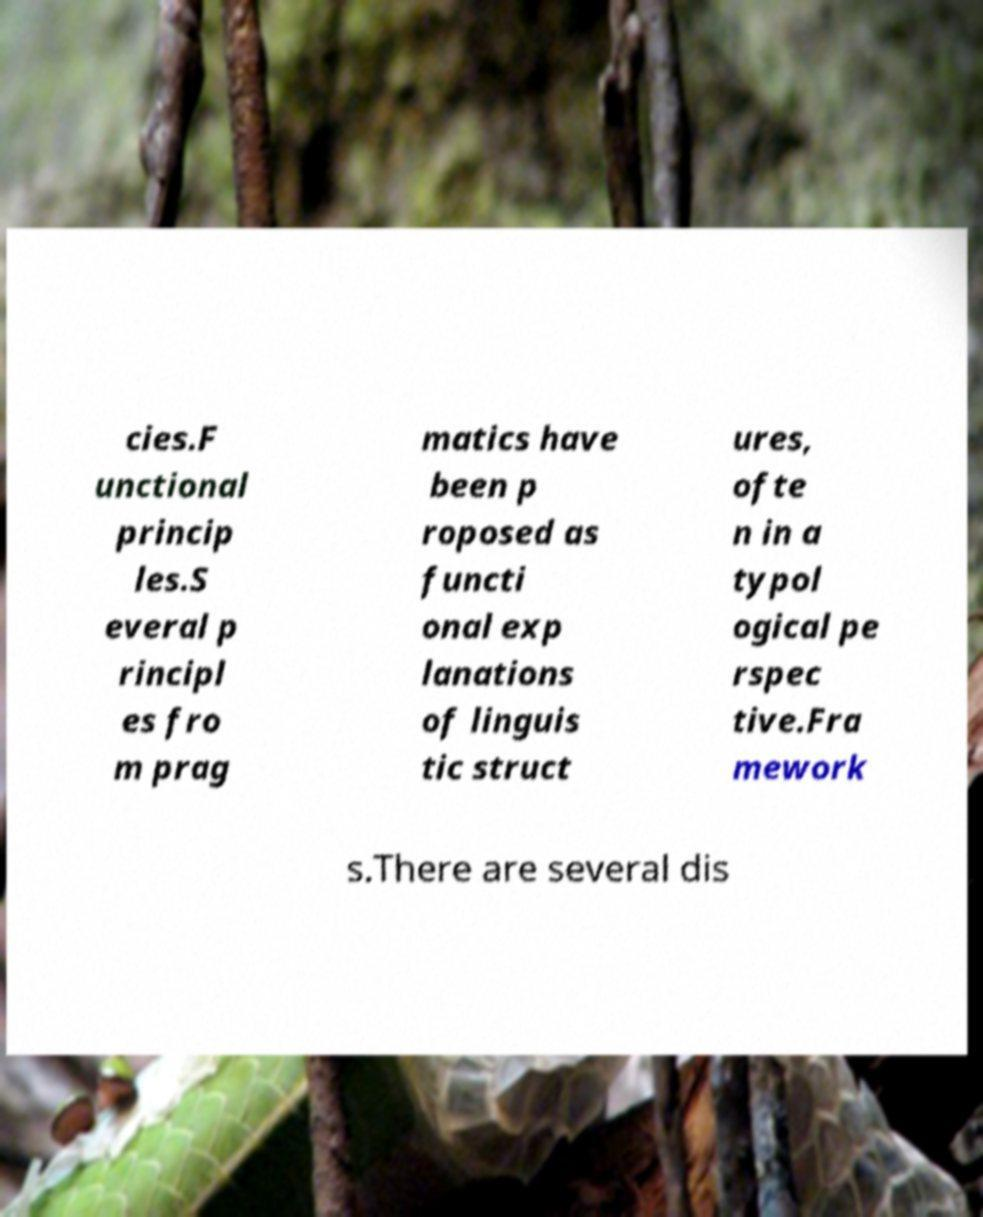Can you read and provide the text displayed in the image?This photo seems to have some interesting text. Can you extract and type it out for me? cies.F unctional princip les.S everal p rincipl es fro m prag matics have been p roposed as functi onal exp lanations of linguis tic struct ures, ofte n in a typol ogical pe rspec tive.Fra mework s.There are several dis 